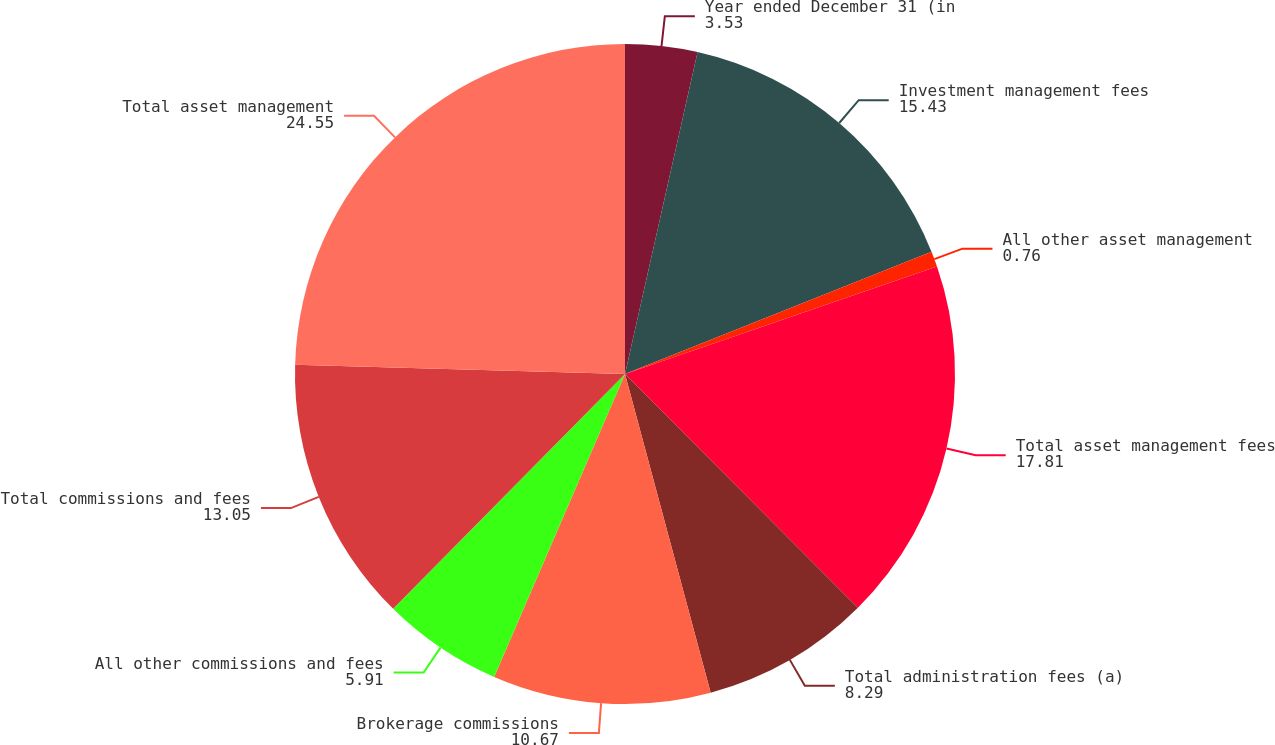Convert chart to OTSL. <chart><loc_0><loc_0><loc_500><loc_500><pie_chart><fcel>Year ended December 31 (in<fcel>Investment management fees<fcel>All other asset management<fcel>Total asset management fees<fcel>Total administration fees (a)<fcel>Brokerage commissions<fcel>All other commissions and fees<fcel>Total commissions and fees<fcel>Total asset management<nl><fcel>3.53%<fcel>15.43%<fcel>0.76%<fcel>17.81%<fcel>8.29%<fcel>10.67%<fcel>5.91%<fcel>13.05%<fcel>24.55%<nl></chart> 